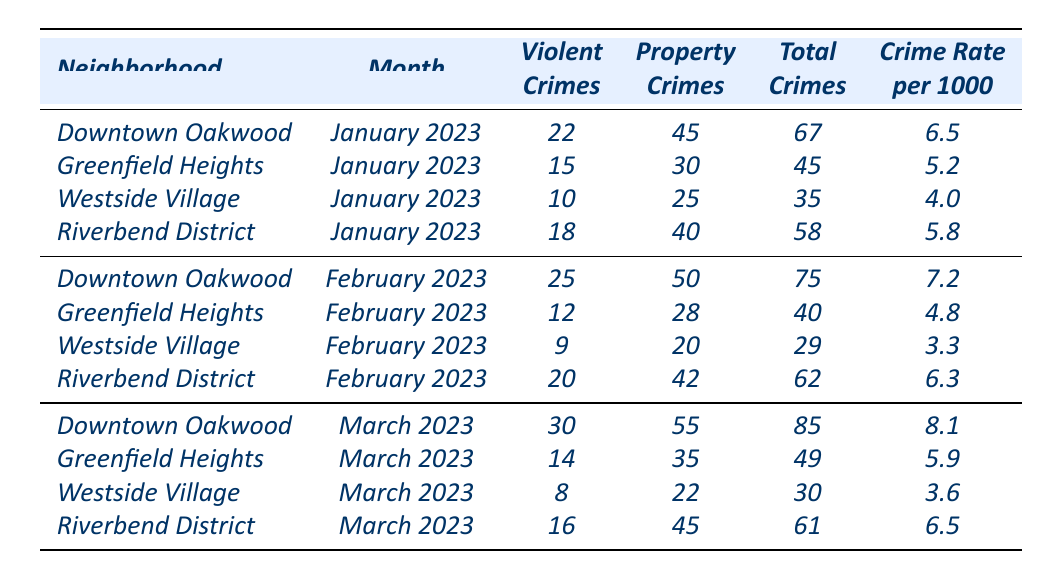What was the total number of violent crimes reported in Downtown Oakwood for March 2023? In March 2023, Downtown Oakwood reported 30 violent crimes as stated in the table.
Answer: 30 Which neighborhood had the highest crime rate in January 2023? The table shows that Downtown Oakwood had the highest crime rate of 6.5 per 1000 in January 2023.
Answer: Downtown Oakwood What is the difference in total crimes between February and March 2023 in Riverbend District? For February 2023, Riverbend District had 62 total crimes, and for March 2023, there were 61 total crimes. The difference is 62 - 61 = 1.
Answer: 1 What is the average number of property crimes reported across all neighborhoods in January 2023? The total property crimes for January are 45 (Downtown Oakwood) + 30 (Greenfield Heights) + 25 (Westside Village) + 40 (Riverbend District) = 140. There are 4 neighborhoods, so the average is 140/4 = 35.
Answer: 35 Did Westside Village have a lower crime rate than Greenfield Heights in March 2023? In March 2023, Westside Village had a crime rate of 3.6, while Greenfield Heights had a crime rate of 5.9. Since 3.6 is less than 5.9, the statement is true.
Answer: Yes How many total crimes were reported in Greenfield Heights over the three months? The total crimes for Greenfield Heights are 45 (January) + 40 (February) + 49 (March) = 134.
Answer: 134 Which neighborhood experienced the highest increase in total crimes from January to March 2023? Comparing the total crimes for each neighborhood: Downtown Oakwood increased from 67 to 85, Greenfield Heights from 45 to 49, Westside Village from 35 to 30 (decrease), and Riverbend District from 58 to 61. Downtown Oakwood had the highest increase of 18.
Answer: Downtown Oakwood What is the ratio of violent crimes to property crimes in January 2023 for Westside Village? In January 2023, Westside Village had 10 violent crimes and 25 property crimes. The ratio is 10:25, which simplifies to 2:5.
Answer: 2:5 